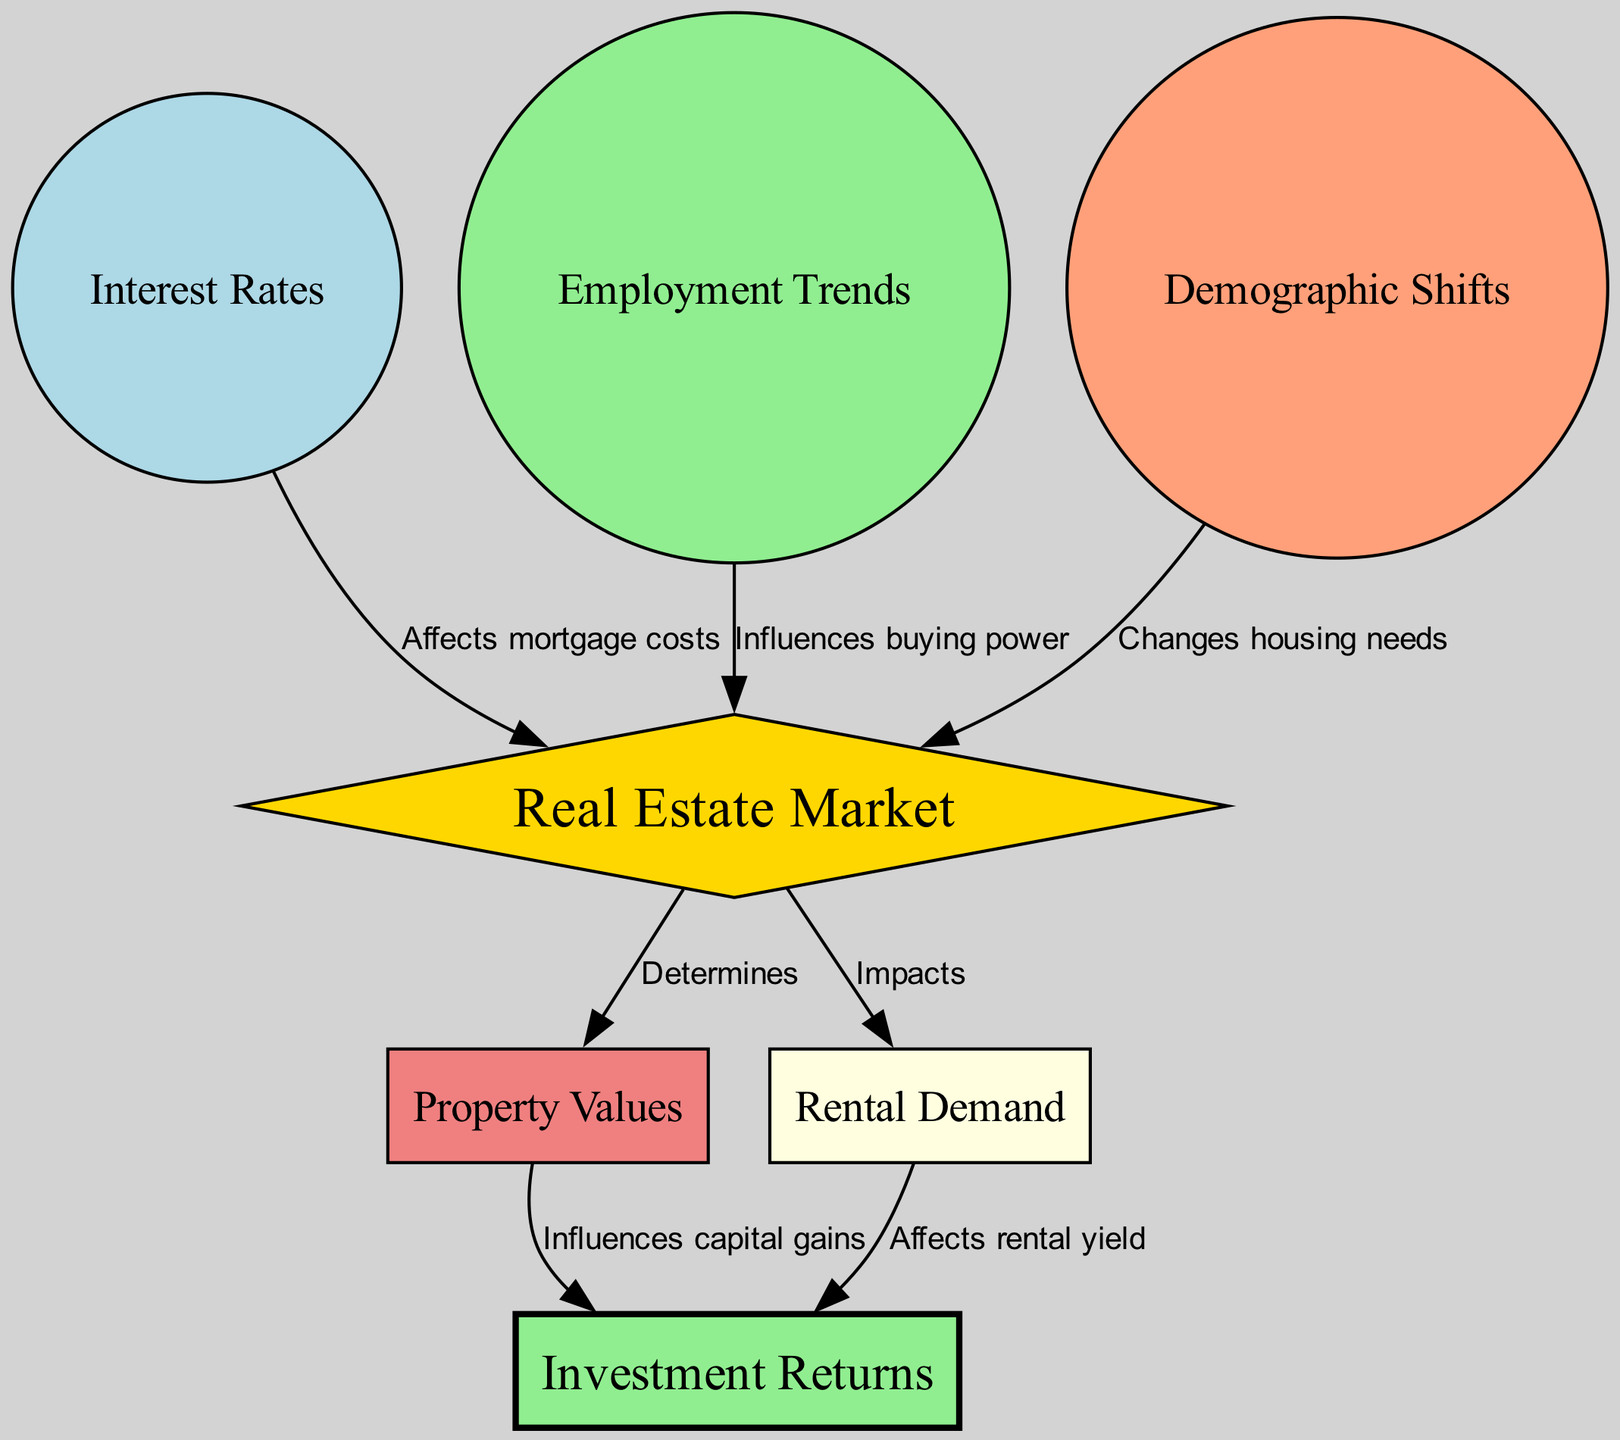What is the central node in the diagram? The central node represented in the diagram is "Real Estate Market," indicated as the main focus of the relationships and influences from other factors.
Answer: Real Estate Market How many factors influence the real estate market? The diagram shows three factors influencing the real estate market: interest rates, employment trends, and demographic shifts, which are directly connected to the central node.
Answer: Three What affects mortgage costs? The diagram specifies that "Interest Rates" affect mortgage costs, showing a direct relationship from interest rates to the real estate market node.
Answer: Interest Rates Which node influences capital gains? "Property Values" is the node that influences capital gains, as shown by the edge connecting it to "Investment Returns."
Answer: Property Values What type of demand is impacted by the real estate market? According to the diagram, "Rental Demand" is impacted by the real estate market, illustrating how the market affects rental demand directly.
Answer: Rental Demand How do employment trends influence the real estate market? Employment trends influence the real estate market by affecting buying power, as indicated by the directional edge from employment trends to the real estate market node.
Answer: Influences buying power What relationship exists between rental demand and investment returns? The diagram indicates that rental demand affects investment returns, demonstrating that higher rental demand can lead to better returns on investments.
Answer: Affects rental yield Which factor changes housing needs? "Demographic Shifts" is the factor that changes housing needs, showing its direct influence on the real estate market in the diagram.
Answer: Demographic Shifts What color is used for the "Real Estate Market" node? The "Real Estate Market" node is displayed in gold, highlighting its significance as the central element in the diagram.
Answer: Gold 